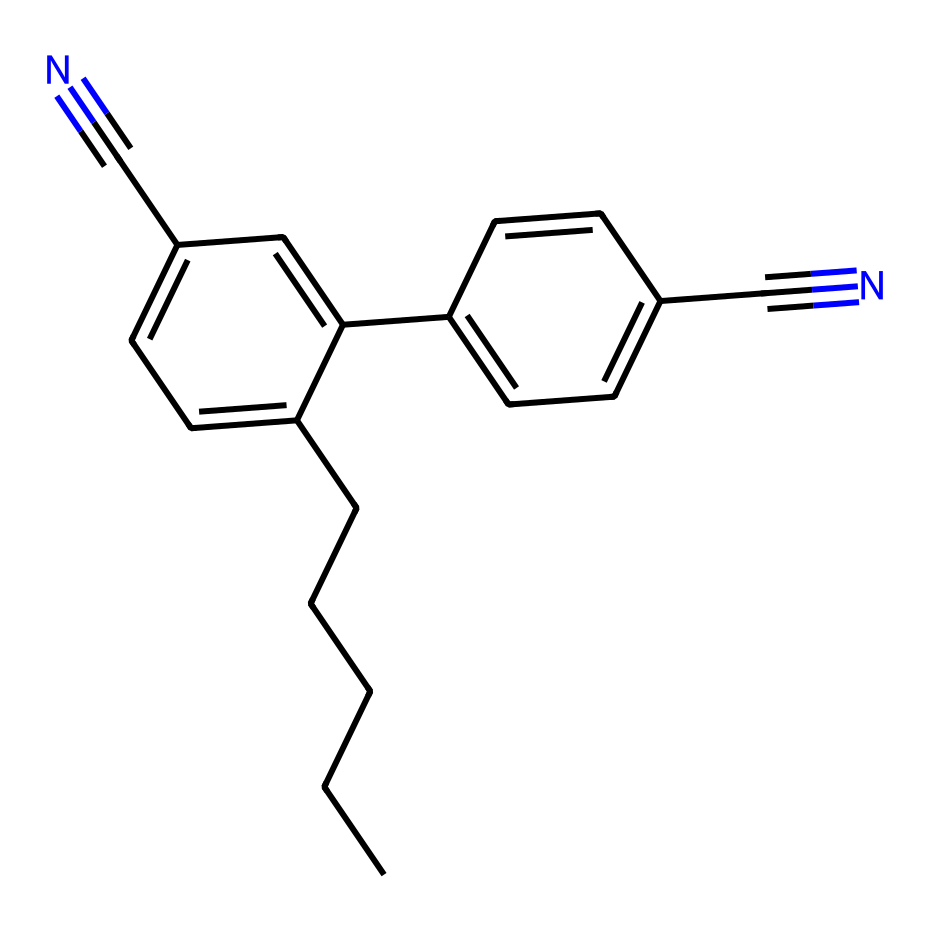How many carbon atoms are present in this chemical? To determine the number of carbon atoms, we can analyze the SMILES representation. The representation gives us a clear count of 'C' symbols. In total, there are 16 carbon atoms in the molecule.
Answer: 16 What functional groups are present in this chemical? By examining the chemical structure represented by the SMILES, we notice the presence of nitrile groups indicated by the 'C#N' sections. Therefore, the functional groups present are nitriles.
Answer: nitriles How many double bonds are found in this chemical? We must evaluate the chemical structure to count the double bonds. There are three double bonds visible in the structure connected to various carbon atoms.
Answer: 3 What is the molecular formula of this compound? To derive the molecular formula, we consider the contributions of each atom type (Carbon, Hydrogen, Nitrogen). This results in the formula C16H18N2.
Answer: C16H18N2 What type of solid does this compound likely form? Given the extended aromatic rings and the presence of sp2 hybridized carbon, this compound is likely to form a crystalline solid. The molecular interactions suggest a stable structure.
Answer: crystalline Does this compound have any polar features? In analyzing the SMILES, we find that the presence of nitrile groups contributes to polarity due to the electronegative nitrogen atoms. Therefore, the compound does exhibit polar features.
Answer: yes How does the molecular arrangement affect the liquid crystal properties in displays? The presence of rigid and flexible regions due to the aromatic rings helps in responsiveness to electric fields in liquid crystal displays. The molecular design supports alignment needed for LCD functionality.
Answer: supports alignment 